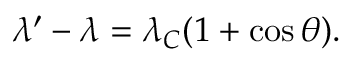Convert formula to latex. <formula><loc_0><loc_0><loc_500><loc_500>\lambda ^ { \prime } - \lambda = \lambda _ { C } ( 1 + \cos { \theta } ) .</formula> 